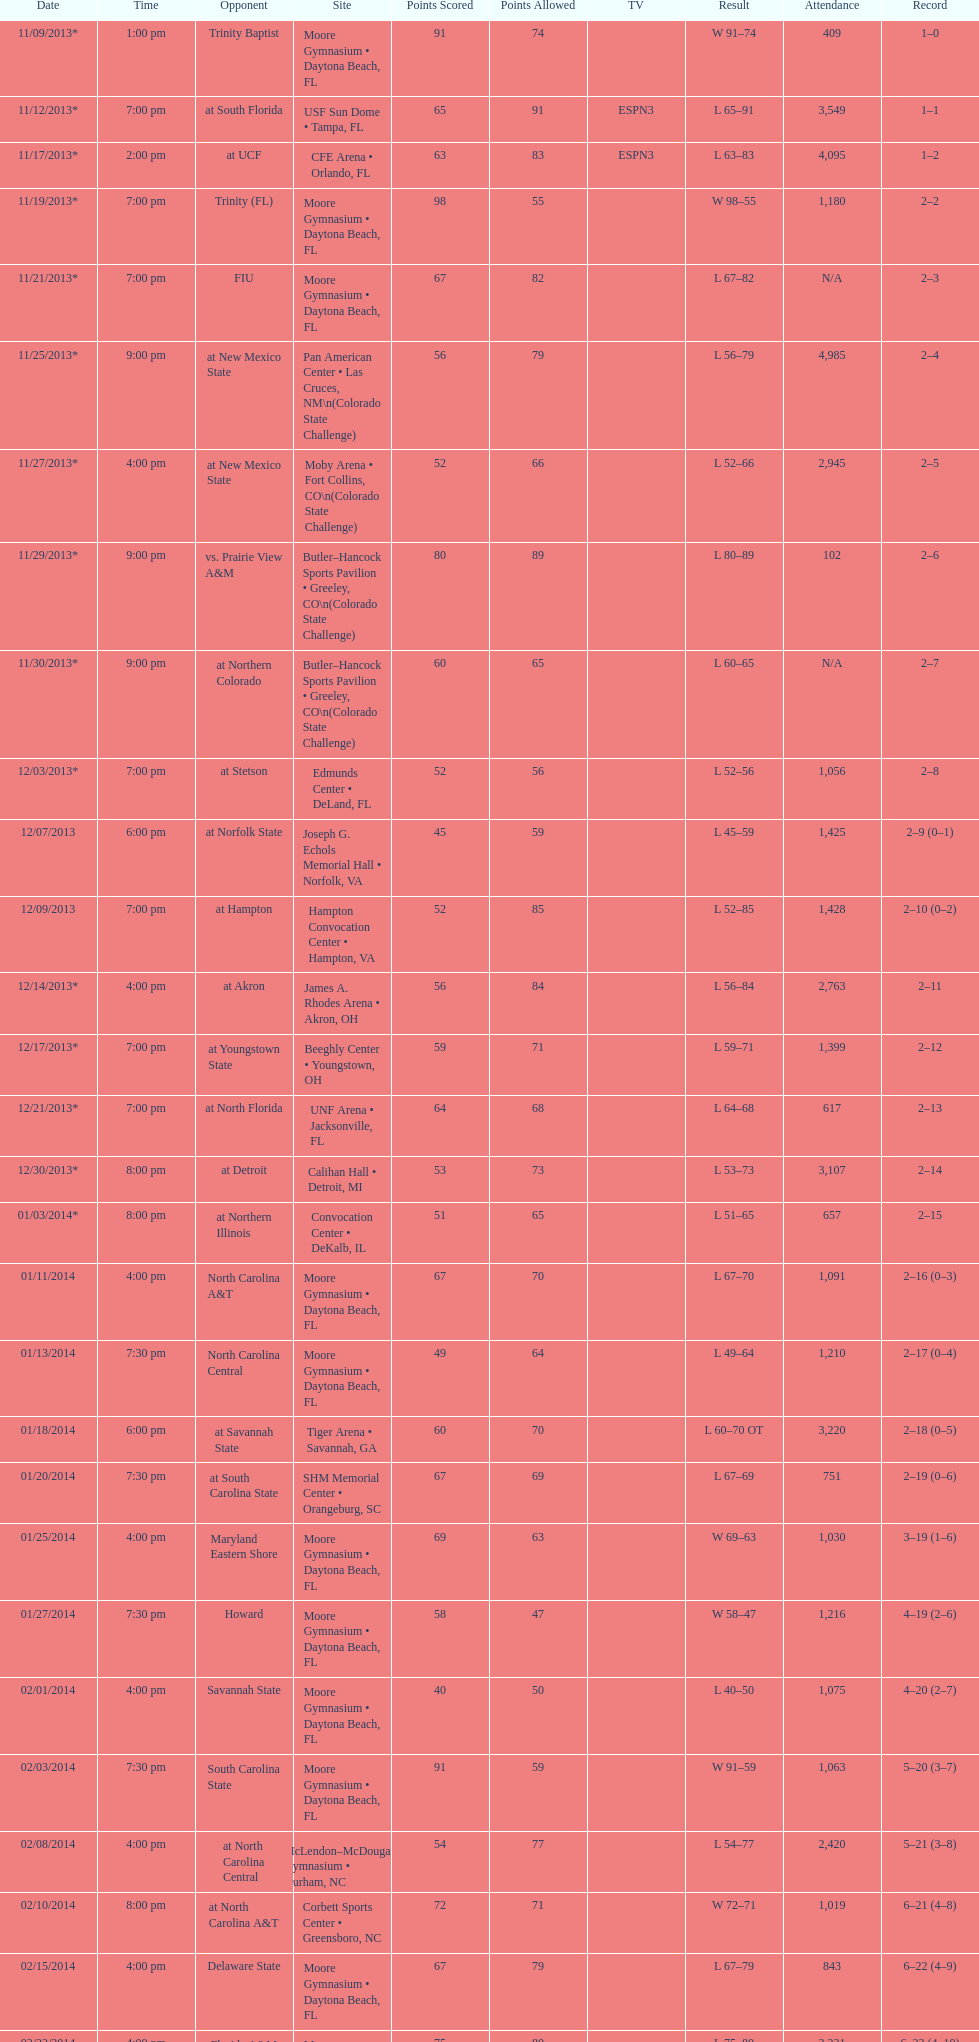Which game was later at night, fiu or northern colorado? Northern Colorado. 